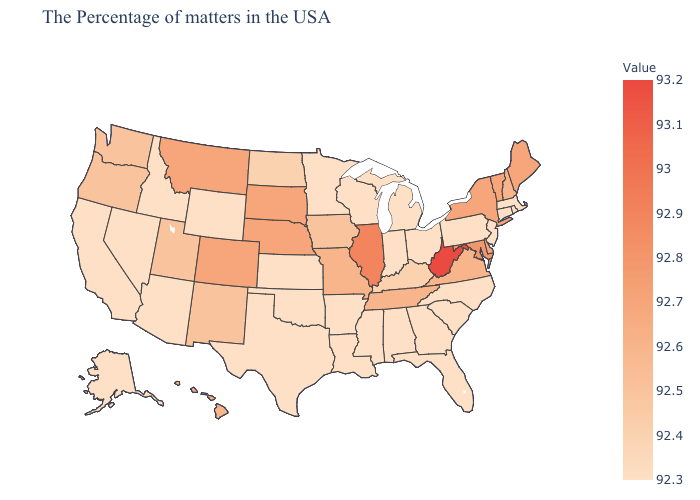Which states hav the highest value in the Northeast?
Give a very brief answer. Maine, Vermont, New York. Does Nevada have the highest value in the USA?
Be succinct. No. Does Iowa have a lower value than Arizona?
Be succinct. No. Is the legend a continuous bar?
Quick response, please. Yes. Does Georgia have the lowest value in the USA?
Be succinct. Yes. Among the states that border Connecticut , which have the highest value?
Write a very short answer. New York. Does Hawaii have the lowest value in the USA?
Write a very short answer. No. Does Florida have the lowest value in the USA?
Short answer required. Yes. Among the states that border Florida , which have the highest value?
Keep it brief. Georgia, Alabama. 